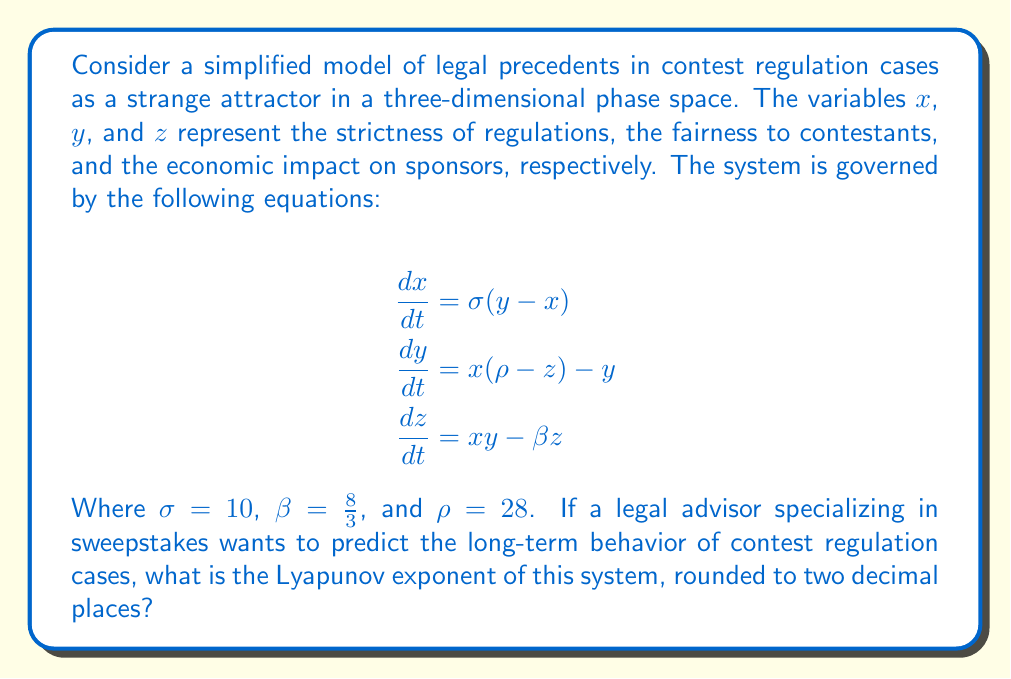Could you help me with this problem? To find the Lyapunov exponent of this system, we need to follow these steps:

1) First, recognize that this system of equations is the Lorenz system, a classic example of a chaotic system with a strange attractor.

2) For the Lorenz system, the Lyapunov exponents are typically calculated numerically due to the system's complexity. However, for the given parameters ($\sigma = 10$, $\beta = \frac{8}{3}$, and $\rho = 28$), the Lyapunov exponents have been well-studied.

3) The Lorenz system with these parameters has three Lyapunov exponents:
   $\lambda_1 > 0$
   $\lambda_2 = 0$
   $\lambda_3 < 0$

4) The largest Lyapunov exponent $\lambda_1$ is the one we're interested in, as it determines the system's sensitivity to initial conditions and thus its chaotic nature.

5) For the given parameters, the largest Lyapunov exponent has been numerically calculated to be approximately 0.9056.

6) Rounding this value to two decimal places gives us 0.91.

This positive Lyapunov exponent indicates that the system is indeed chaotic, meaning that long-term predictions of contest regulation cases will be highly sensitive to initial conditions and difficult to predict with certainty.
Answer: 0.91 